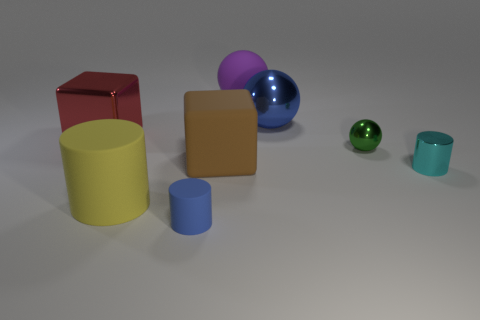Does the tiny matte cylinder have the same color as the large shiny ball?
Provide a short and direct response. Yes. There is a large sphere that is the same color as the small matte thing; what material is it?
Provide a short and direct response. Metal. Is there a sphere that has the same color as the tiny matte object?
Offer a terse response. Yes. Is the number of big blocks in front of the large yellow matte object less than the number of big yellow metallic things?
Offer a terse response. No. There is a tiny green object behind the large brown rubber object; is there a red block behind it?
Your answer should be very brief. Yes. Does the yellow cylinder have the same size as the brown block?
Your answer should be compact. Yes. The blue thing behind the big cube to the left of the large matte thing that is in front of the small cyan shiny thing is made of what material?
Keep it short and to the point. Metal. Are there the same number of blocks that are behind the large blue ball and tiny gray rubber balls?
Ensure brevity in your answer.  Yes. How many objects are blue balls or large red shiny balls?
Offer a terse response. 1. What shape is the big red object that is made of the same material as the small cyan thing?
Your answer should be very brief. Cube. 